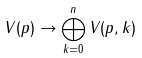<formula> <loc_0><loc_0><loc_500><loc_500>V ( p ) \rightarrow \bigoplus _ { k = 0 } ^ { n } V ( p , k )</formula> 